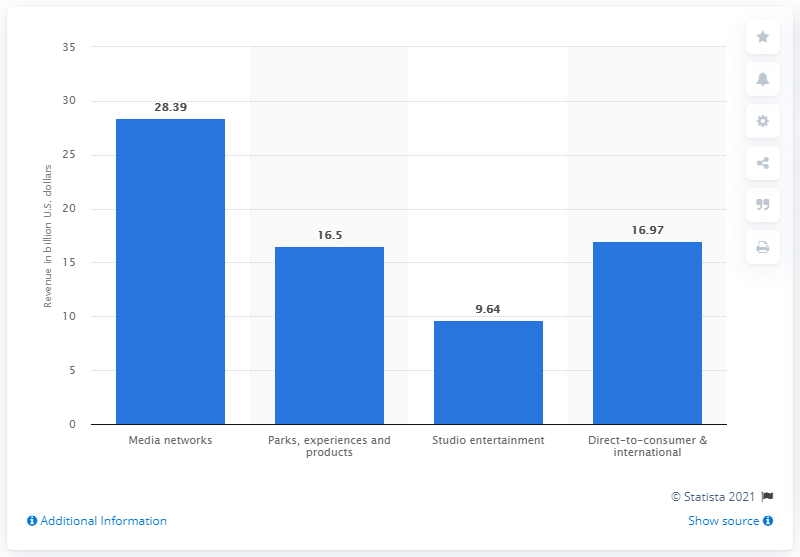Mention a couple of crucial points in this snapshot. The media networks generated $28.39 million in revenue in 2020. The value of the lowest bar on the graph is 9.64. In 2020, the Walt Disney Company's parks and resorts segment generated a total revenue of 16.5 billion U.S. dollars. 